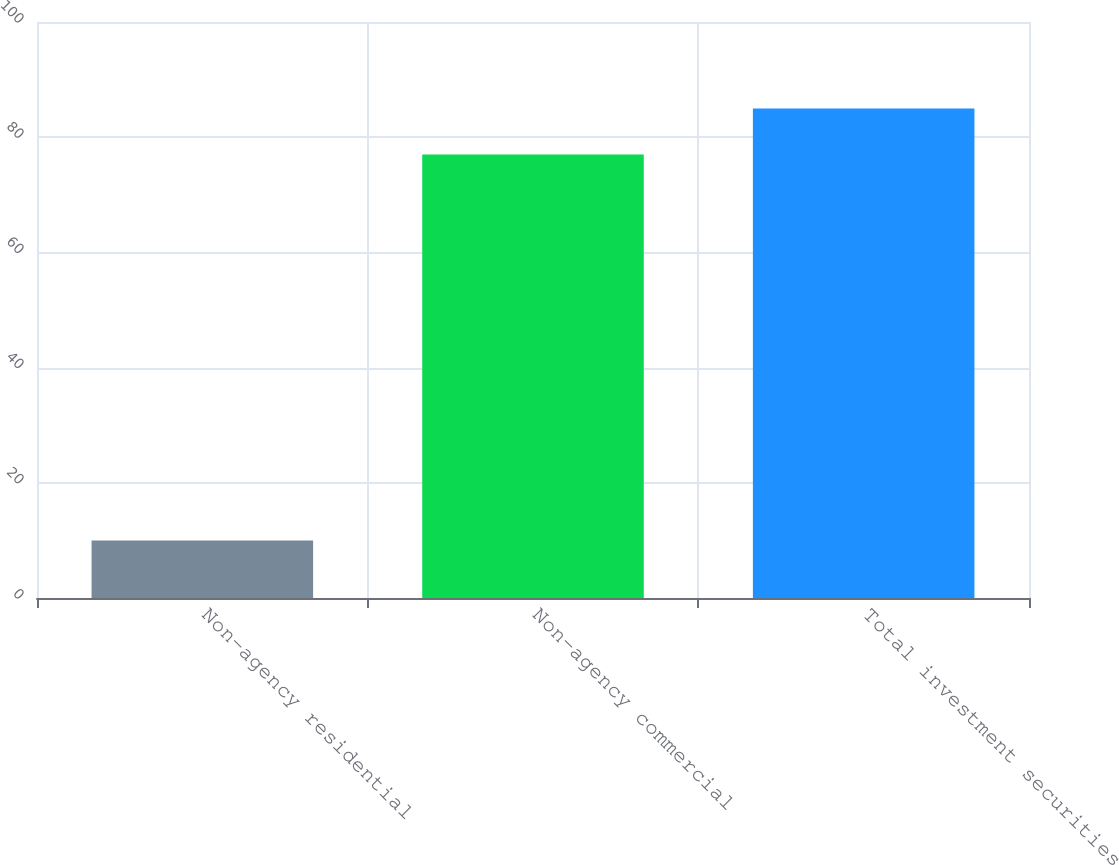Convert chart. <chart><loc_0><loc_0><loc_500><loc_500><bar_chart><fcel>Non-agency residential<fcel>Non-agency commercial<fcel>Total investment securities<nl><fcel>10<fcel>77<fcel>85<nl></chart> 